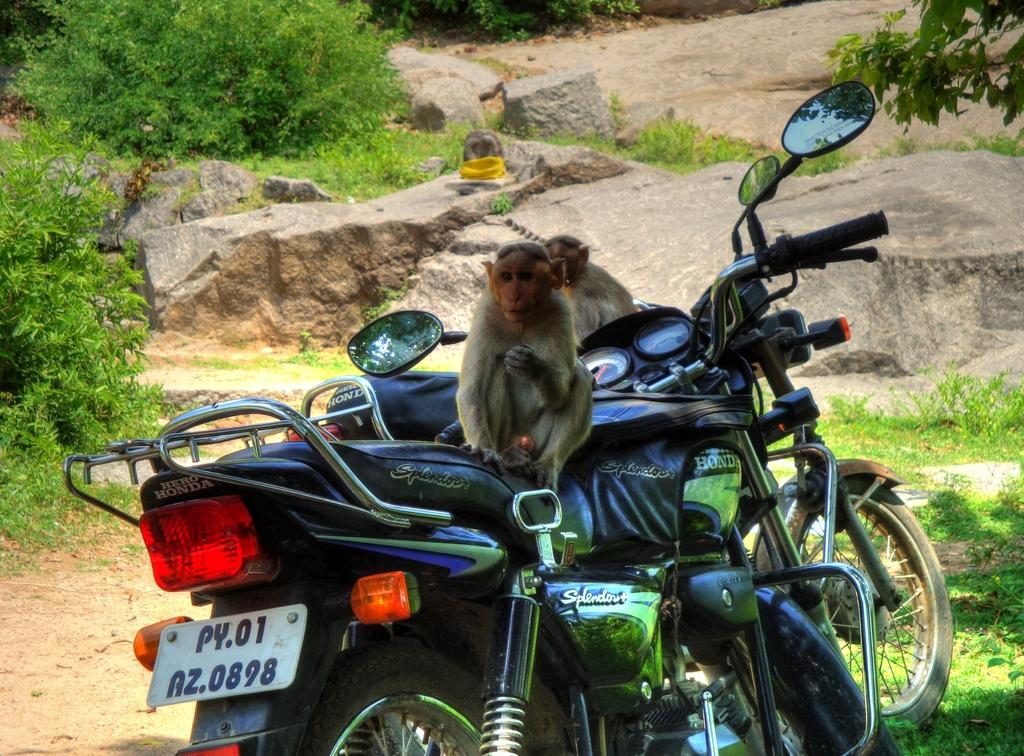What animals are present in the image? There are monkeys in the image. What are the monkeys doing in the image? The monkeys are sitting on bikes. What can be seen in the background of the image? There are rocks and trees in the background of the image. What is visible at the bottom of the image? There is ground visible at the bottom of the image. What type of clover can be seen growing on the ground in the image? There is no clover visible in the image; the ground is covered by rocks and trees in the background. 